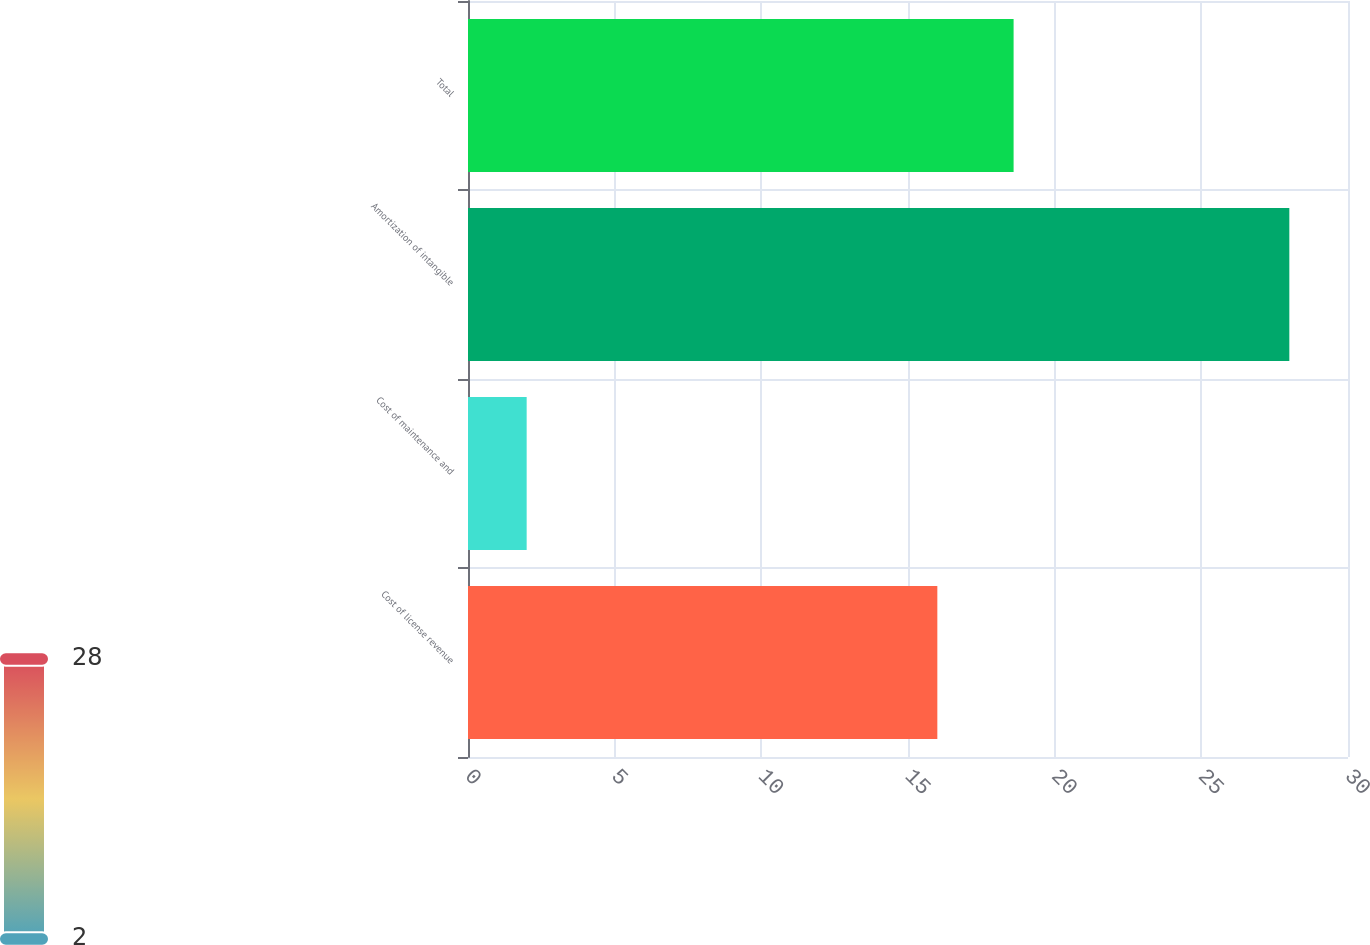Convert chart. <chart><loc_0><loc_0><loc_500><loc_500><bar_chart><fcel>Cost of license revenue<fcel>Cost of maintenance and<fcel>Amortization of intangible<fcel>Total<nl><fcel>16<fcel>2<fcel>28<fcel>18.6<nl></chart> 